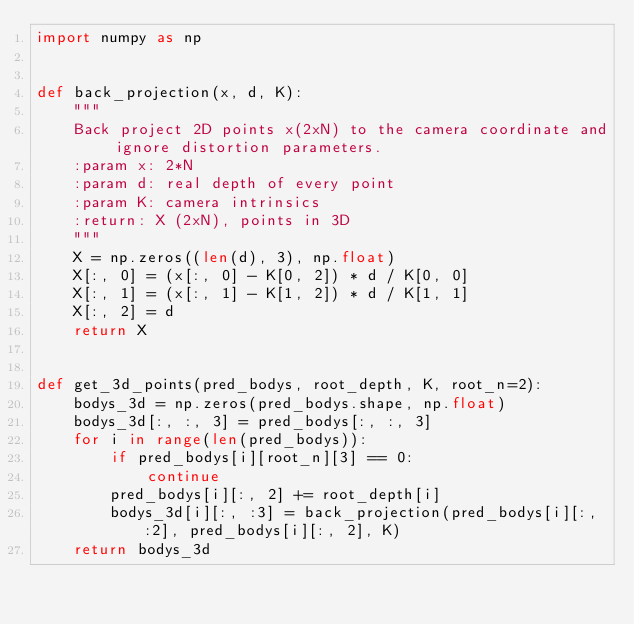Convert code to text. <code><loc_0><loc_0><loc_500><loc_500><_Python_>import numpy as np


def back_projection(x, d, K):
    """
    Back project 2D points x(2xN) to the camera coordinate and ignore distortion parameters.
    :param x: 2*N
    :param d: real depth of every point
    :param K: camera intrinsics
    :return: X (2xN), points in 3D
    """
    X = np.zeros((len(d), 3), np.float)
    X[:, 0] = (x[:, 0] - K[0, 2]) * d / K[0, 0]
    X[:, 1] = (x[:, 1] - K[1, 2]) * d / K[1, 1]
    X[:, 2] = d
    return X


def get_3d_points(pred_bodys, root_depth, K, root_n=2):
    bodys_3d = np.zeros(pred_bodys.shape, np.float)
    bodys_3d[:, :, 3] = pred_bodys[:, :, 3]
    for i in range(len(pred_bodys)):
        if pred_bodys[i][root_n][3] == 0:
            continue
        pred_bodys[i][:, 2] += root_depth[i]
        bodys_3d[i][:, :3] = back_projection(pred_bodys[i][:, :2], pred_bodys[i][:, 2], K)
    return bodys_3d</code> 